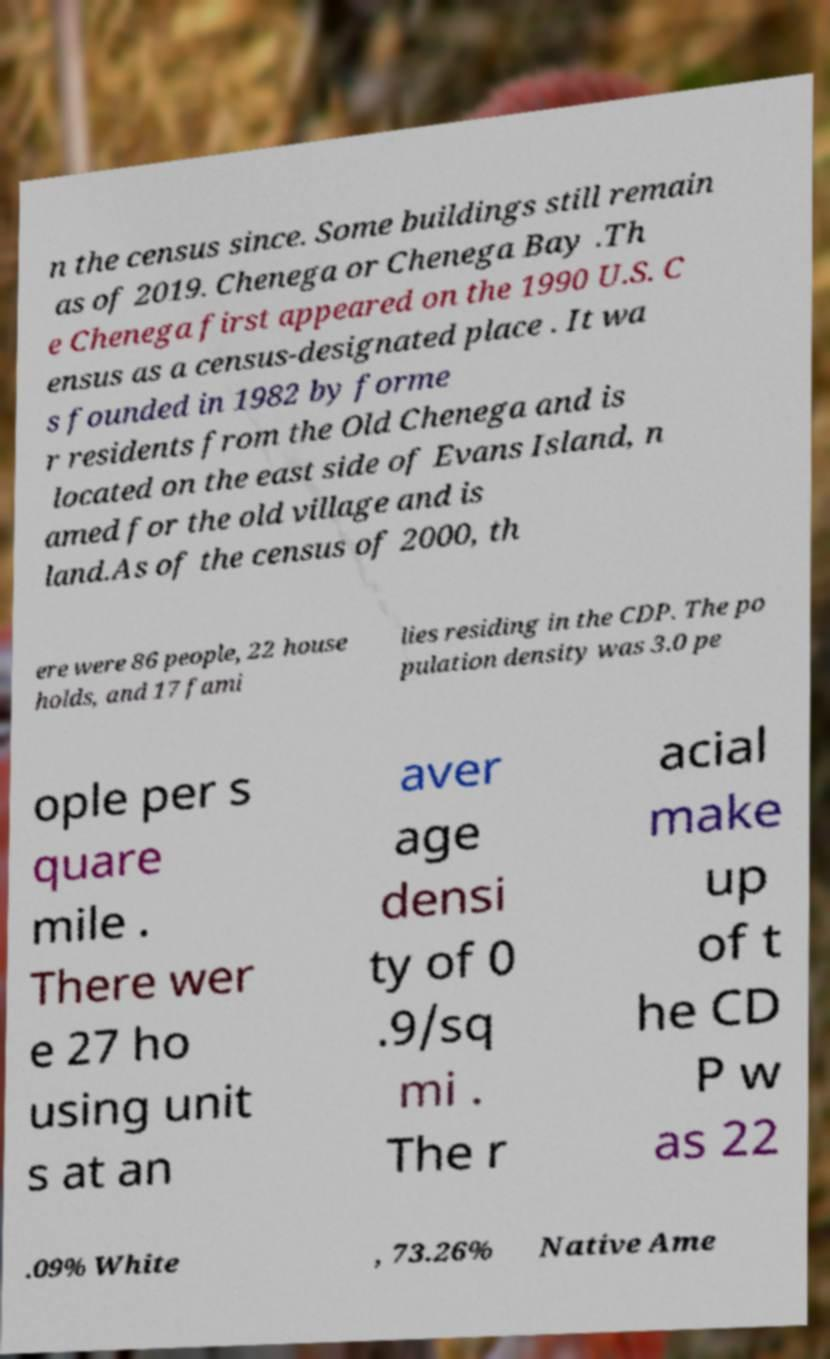Please read and relay the text visible in this image. What does it say? n the census since. Some buildings still remain as of 2019. Chenega or Chenega Bay .Th e Chenega first appeared on the 1990 U.S. C ensus as a census-designated place . It wa s founded in 1982 by forme r residents from the Old Chenega and is located on the east side of Evans Island, n amed for the old village and is land.As of the census of 2000, th ere were 86 people, 22 house holds, and 17 fami lies residing in the CDP. The po pulation density was 3.0 pe ople per s quare mile . There wer e 27 ho using unit s at an aver age densi ty of 0 .9/sq mi . The r acial make up of t he CD P w as 22 .09% White , 73.26% Native Ame 